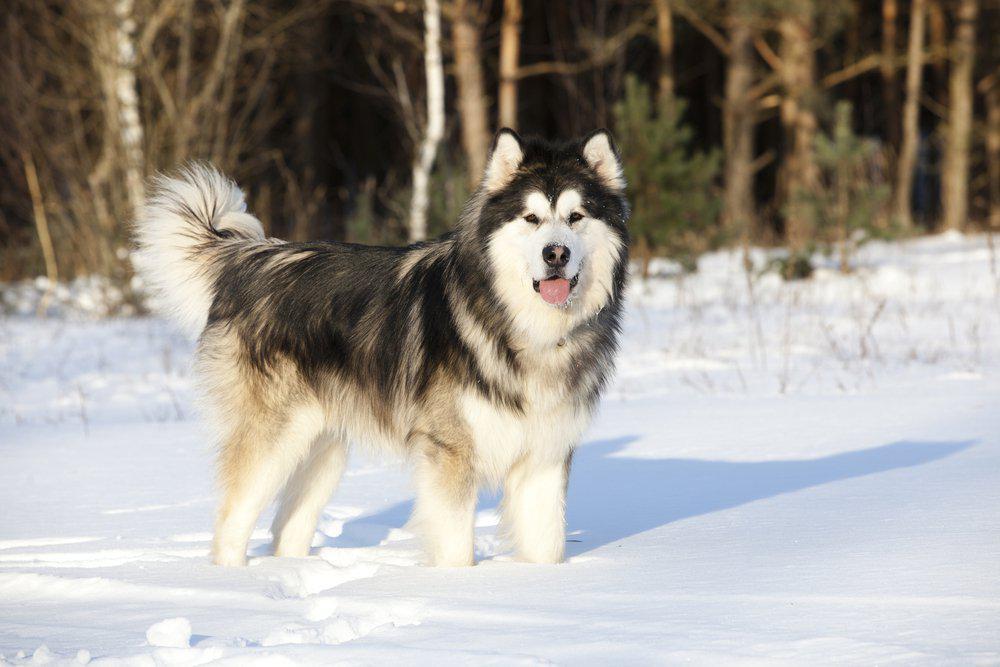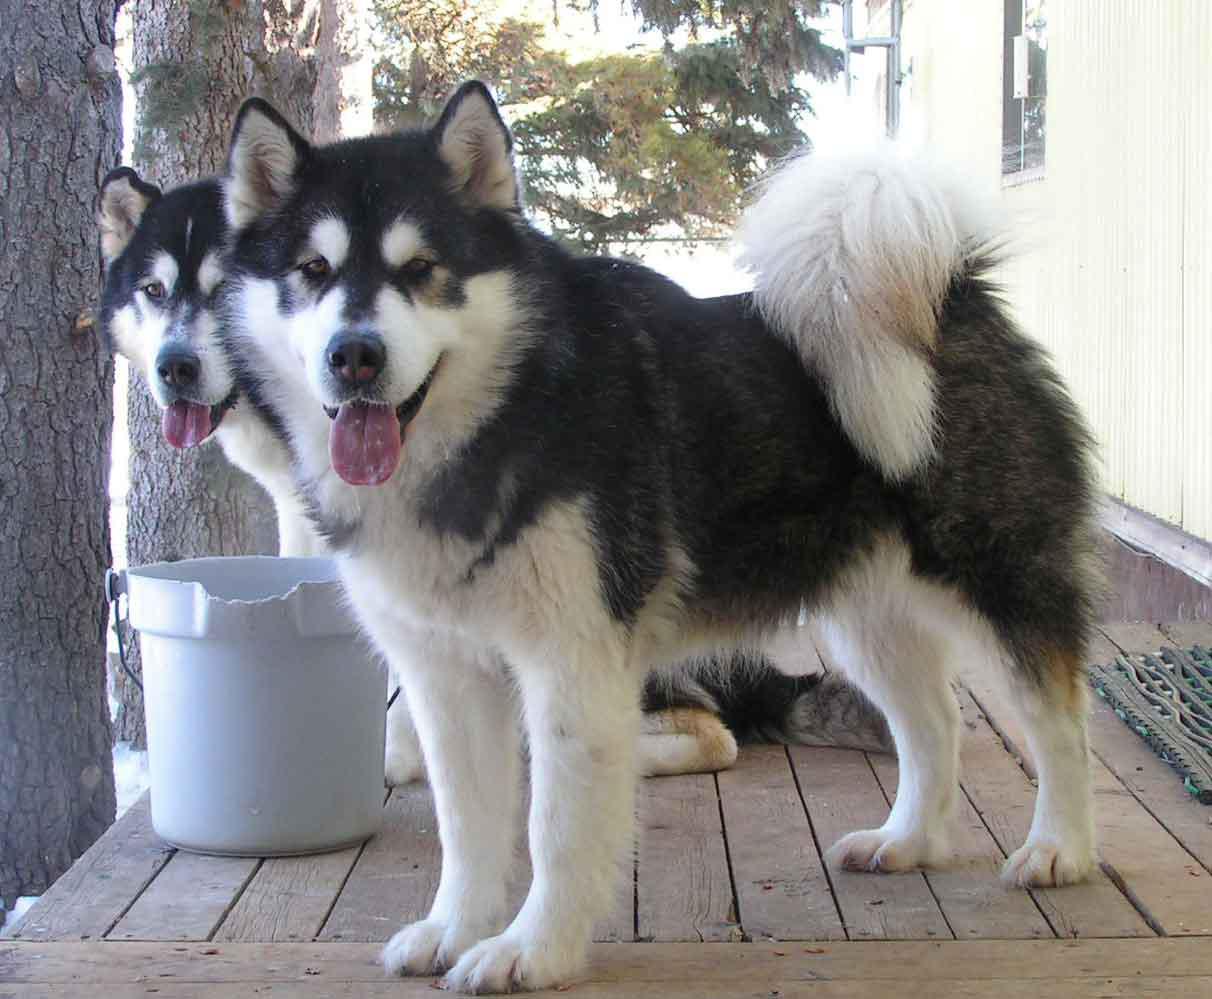The first image is the image on the left, the second image is the image on the right. Analyze the images presented: Is the assertion "The left image includes two huskies side-by-side on snowy ground, and the right image includes one woman with at least one husky." valid? Answer yes or no. No. 